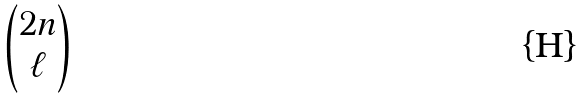Convert formula to latex. <formula><loc_0><loc_0><loc_500><loc_500>\begin{pmatrix} 2 n \\ \ell \end{pmatrix}</formula> 